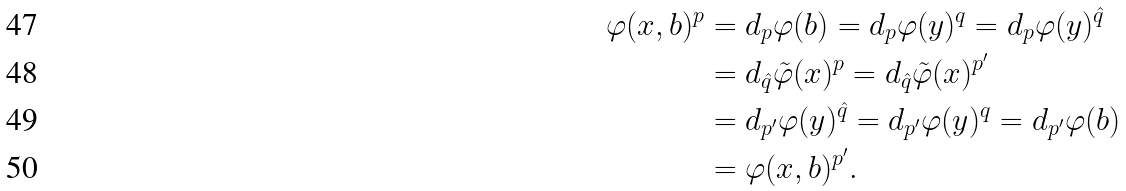<formula> <loc_0><loc_0><loc_500><loc_500>\varphi ( x , b ) ^ { p } & = d _ { p } \varphi ( b ) = d _ { p } \varphi ( y ) ^ { q } = d _ { p } \varphi ( y ) ^ { \hat { q } } \\ & = d _ { \hat { q } } \tilde { \varphi } ( x ) ^ { p } = d _ { \hat { q } } \tilde { \varphi } ( x ) ^ { p ^ { \prime } } \\ & = d _ { p ^ { \prime } } \varphi ( y ) ^ { \hat { q } } = d _ { p ^ { \prime } } \varphi ( y ) ^ { q } = d _ { p ^ { \prime } } \varphi ( b ) \\ & = \varphi ( x , b ) ^ { p ^ { \prime } } .</formula> 